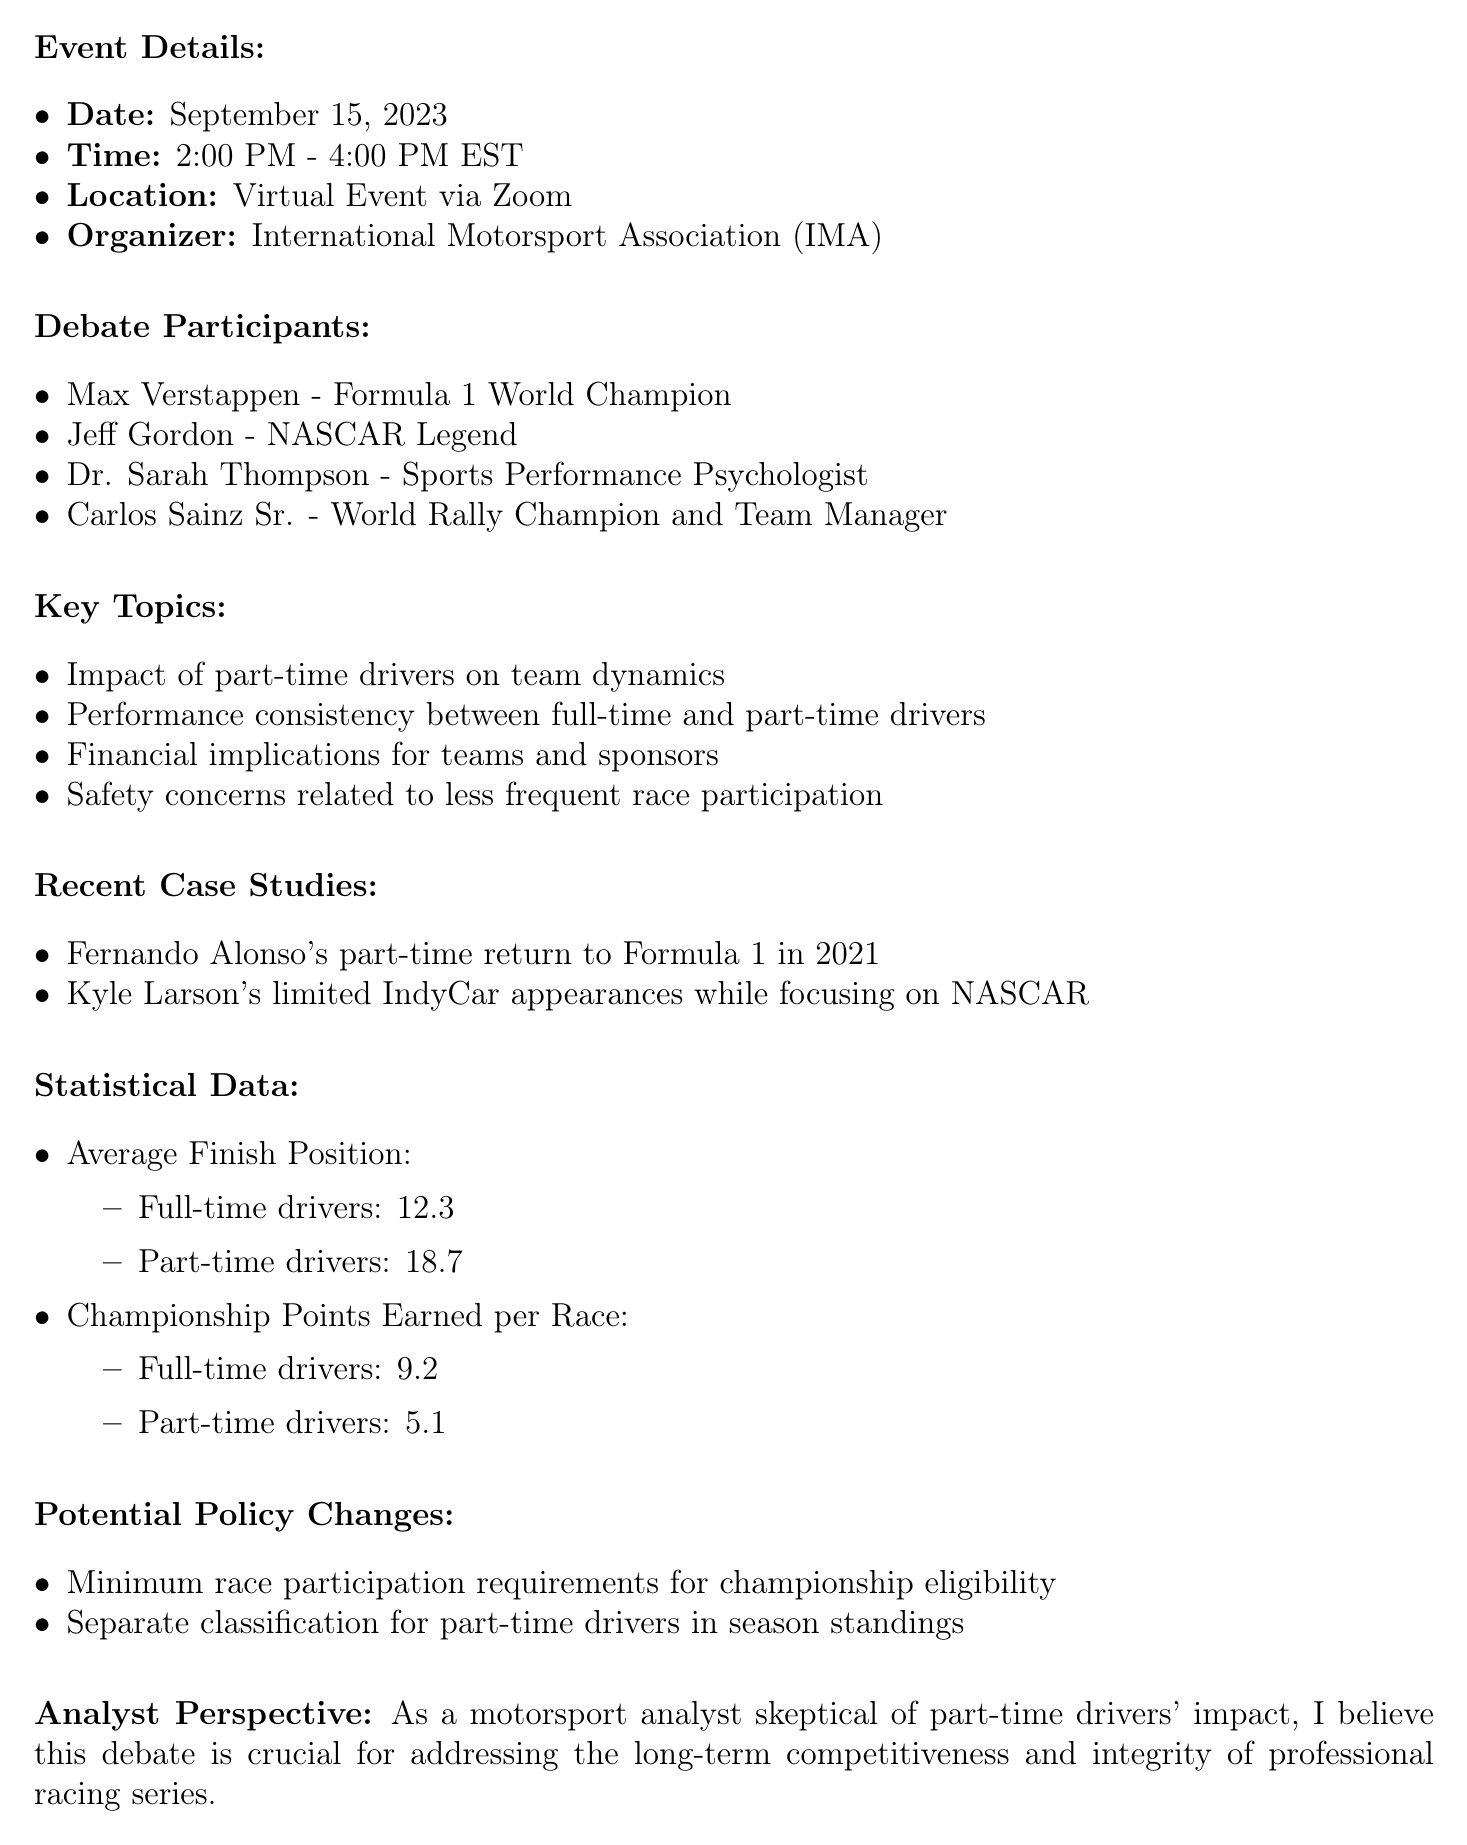What is the date of the debate? The date of the debate is explicitly mentioned in the document.
Answer: September 15, 2023 Who is one of the debate participants known for being a Formula 1 World Champion? The document lists notable participants, and one is specifically identified as a Formula 1 World Champion.
Answer: Max Verstappen What is the average finish position of part-time drivers? The document provides statistical data regarding average finish positions for both full-time and part-time drivers.
Answer: 18.7 What key topic addresses financial implications? The document outlines key topics, including one that specifically mentions financial aspects.
Answer: Financial implications for teams and sponsors What potential policy change relates to race participation eligibility? The document describes potential changes, including one concerning race participation requirements for championships.
Answer: Minimum race participation requirements for championship eligibility Which recent case study involves Fernando Alonso? The document includes a section on recent case studies that discusses Alonso's situation.
Answer: Fernando Alonso's part-time return to Formula 1 in 2021 How long is the debate scheduled to last? The event details specify the duration of the debate from its start to end time.
Answer: 2 hours What is the average championship points earned per race by full-time drivers? The document presents a comparison of championship points earned by full-time and part-time drivers.
Answer: 9.2 